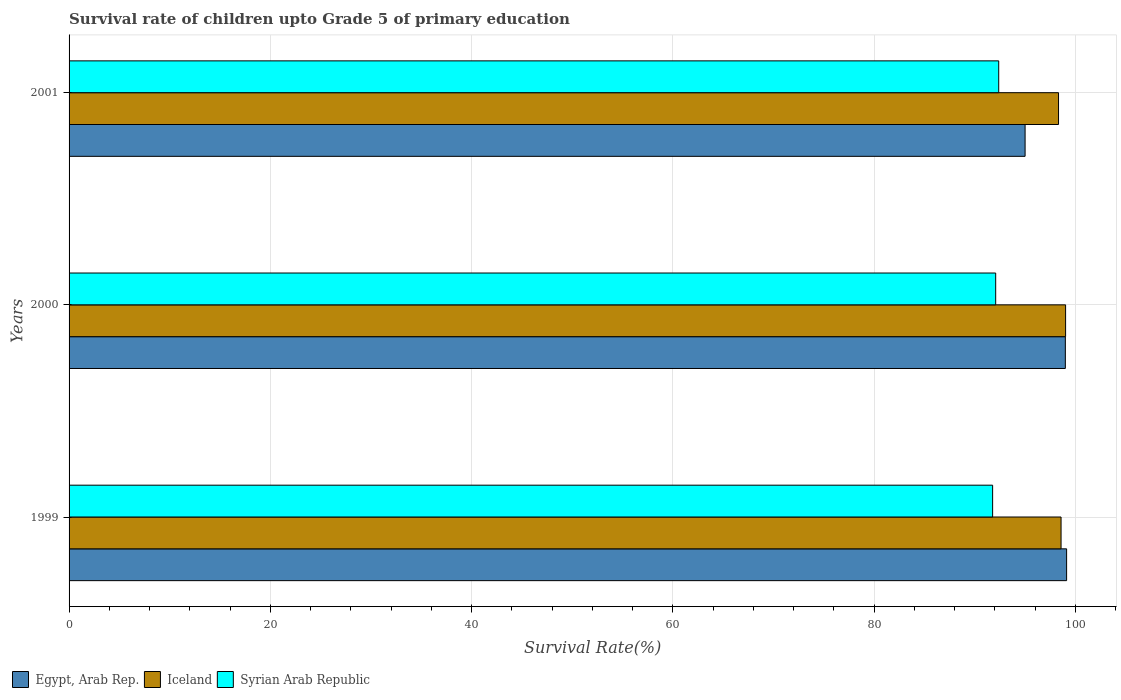Are the number of bars per tick equal to the number of legend labels?
Make the answer very short. Yes. Are the number of bars on each tick of the Y-axis equal?
Give a very brief answer. Yes. How many bars are there on the 3rd tick from the top?
Make the answer very short. 3. How many bars are there on the 2nd tick from the bottom?
Your answer should be very brief. 3. What is the label of the 2nd group of bars from the top?
Offer a terse response. 2000. What is the survival rate of children in Egypt, Arab Rep. in 1999?
Ensure brevity in your answer.  99.12. Across all years, what is the maximum survival rate of children in Egypt, Arab Rep.?
Provide a succinct answer. 99.12. Across all years, what is the minimum survival rate of children in Egypt, Arab Rep.?
Ensure brevity in your answer.  95. In which year was the survival rate of children in Iceland maximum?
Offer a very short reply. 2000. In which year was the survival rate of children in Egypt, Arab Rep. minimum?
Give a very brief answer. 2001. What is the total survival rate of children in Egypt, Arab Rep. in the graph?
Your answer should be very brief. 293.12. What is the difference between the survival rate of children in Iceland in 1999 and that in 2000?
Ensure brevity in your answer.  -0.45. What is the difference between the survival rate of children in Syrian Arab Republic in 2000 and the survival rate of children in Iceland in 2001?
Give a very brief answer. -6.24. What is the average survival rate of children in Egypt, Arab Rep. per year?
Offer a very short reply. 97.71. In the year 2000, what is the difference between the survival rate of children in Egypt, Arab Rep. and survival rate of children in Iceland?
Your answer should be very brief. -0.02. In how many years, is the survival rate of children in Egypt, Arab Rep. greater than 36 %?
Keep it short and to the point. 3. What is the ratio of the survival rate of children in Iceland in 1999 to that in 2001?
Keep it short and to the point. 1. Is the survival rate of children in Iceland in 1999 less than that in 2000?
Provide a short and direct response. Yes. What is the difference between the highest and the second highest survival rate of children in Syrian Arab Republic?
Offer a terse response. 0.3. What is the difference between the highest and the lowest survival rate of children in Egypt, Arab Rep.?
Your response must be concise. 4.13. In how many years, is the survival rate of children in Syrian Arab Republic greater than the average survival rate of children in Syrian Arab Republic taken over all years?
Provide a succinct answer. 2. What does the 1st bar from the top in 2001 represents?
Your response must be concise. Syrian Arab Republic. What does the 1st bar from the bottom in 2001 represents?
Your response must be concise. Egypt, Arab Rep. How many bars are there?
Provide a succinct answer. 9. Are all the bars in the graph horizontal?
Provide a succinct answer. Yes. Does the graph contain any zero values?
Your response must be concise. No. How are the legend labels stacked?
Make the answer very short. Horizontal. What is the title of the graph?
Make the answer very short. Survival rate of children upto Grade 5 of primary education. What is the label or title of the X-axis?
Offer a terse response. Survival Rate(%). What is the Survival Rate(%) of Egypt, Arab Rep. in 1999?
Give a very brief answer. 99.12. What is the Survival Rate(%) in Iceland in 1999?
Your answer should be compact. 98.57. What is the Survival Rate(%) of Syrian Arab Republic in 1999?
Offer a terse response. 91.77. What is the Survival Rate(%) in Egypt, Arab Rep. in 2000?
Your response must be concise. 99. What is the Survival Rate(%) of Iceland in 2000?
Ensure brevity in your answer.  99.02. What is the Survival Rate(%) in Syrian Arab Republic in 2000?
Ensure brevity in your answer.  92.08. What is the Survival Rate(%) of Egypt, Arab Rep. in 2001?
Ensure brevity in your answer.  95. What is the Survival Rate(%) in Iceland in 2001?
Offer a terse response. 98.32. What is the Survival Rate(%) in Syrian Arab Republic in 2001?
Make the answer very short. 92.38. Across all years, what is the maximum Survival Rate(%) of Egypt, Arab Rep.?
Your answer should be very brief. 99.12. Across all years, what is the maximum Survival Rate(%) in Iceland?
Offer a very short reply. 99.02. Across all years, what is the maximum Survival Rate(%) in Syrian Arab Republic?
Provide a succinct answer. 92.38. Across all years, what is the minimum Survival Rate(%) in Egypt, Arab Rep.?
Make the answer very short. 95. Across all years, what is the minimum Survival Rate(%) in Iceland?
Offer a very short reply. 98.32. Across all years, what is the minimum Survival Rate(%) in Syrian Arab Republic?
Provide a short and direct response. 91.77. What is the total Survival Rate(%) of Egypt, Arab Rep. in the graph?
Give a very brief answer. 293.12. What is the total Survival Rate(%) in Iceland in the graph?
Provide a succinct answer. 295.92. What is the total Survival Rate(%) in Syrian Arab Republic in the graph?
Offer a terse response. 276.23. What is the difference between the Survival Rate(%) in Egypt, Arab Rep. in 1999 and that in 2000?
Your response must be concise. 0.13. What is the difference between the Survival Rate(%) of Iceland in 1999 and that in 2000?
Offer a terse response. -0.45. What is the difference between the Survival Rate(%) of Syrian Arab Republic in 1999 and that in 2000?
Give a very brief answer. -0.3. What is the difference between the Survival Rate(%) in Egypt, Arab Rep. in 1999 and that in 2001?
Keep it short and to the point. 4.13. What is the difference between the Survival Rate(%) of Iceland in 1999 and that in 2001?
Make the answer very short. 0.25. What is the difference between the Survival Rate(%) in Syrian Arab Republic in 1999 and that in 2001?
Provide a succinct answer. -0.61. What is the difference between the Survival Rate(%) of Egypt, Arab Rep. in 2000 and that in 2001?
Ensure brevity in your answer.  4. What is the difference between the Survival Rate(%) in Iceland in 2000 and that in 2001?
Ensure brevity in your answer.  0.7. What is the difference between the Survival Rate(%) of Syrian Arab Republic in 2000 and that in 2001?
Offer a terse response. -0.3. What is the difference between the Survival Rate(%) of Egypt, Arab Rep. in 1999 and the Survival Rate(%) of Iceland in 2000?
Provide a succinct answer. 0.1. What is the difference between the Survival Rate(%) in Egypt, Arab Rep. in 1999 and the Survival Rate(%) in Syrian Arab Republic in 2000?
Provide a succinct answer. 7.05. What is the difference between the Survival Rate(%) in Iceland in 1999 and the Survival Rate(%) in Syrian Arab Republic in 2000?
Provide a succinct answer. 6.5. What is the difference between the Survival Rate(%) in Egypt, Arab Rep. in 1999 and the Survival Rate(%) in Iceland in 2001?
Offer a very short reply. 0.8. What is the difference between the Survival Rate(%) in Egypt, Arab Rep. in 1999 and the Survival Rate(%) in Syrian Arab Republic in 2001?
Your answer should be compact. 6.75. What is the difference between the Survival Rate(%) of Iceland in 1999 and the Survival Rate(%) of Syrian Arab Republic in 2001?
Give a very brief answer. 6.19. What is the difference between the Survival Rate(%) of Egypt, Arab Rep. in 2000 and the Survival Rate(%) of Iceland in 2001?
Make the answer very short. 0.68. What is the difference between the Survival Rate(%) in Egypt, Arab Rep. in 2000 and the Survival Rate(%) in Syrian Arab Republic in 2001?
Give a very brief answer. 6.62. What is the difference between the Survival Rate(%) of Iceland in 2000 and the Survival Rate(%) of Syrian Arab Republic in 2001?
Ensure brevity in your answer.  6.64. What is the average Survival Rate(%) of Egypt, Arab Rep. per year?
Give a very brief answer. 97.71. What is the average Survival Rate(%) in Iceland per year?
Your answer should be very brief. 98.64. What is the average Survival Rate(%) of Syrian Arab Republic per year?
Offer a terse response. 92.08. In the year 1999, what is the difference between the Survival Rate(%) in Egypt, Arab Rep. and Survival Rate(%) in Iceland?
Your response must be concise. 0.55. In the year 1999, what is the difference between the Survival Rate(%) in Egypt, Arab Rep. and Survival Rate(%) in Syrian Arab Republic?
Your answer should be compact. 7.35. In the year 1999, what is the difference between the Survival Rate(%) of Iceland and Survival Rate(%) of Syrian Arab Republic?
Offer a terse response. 6.8. In the year 2000, what is the difference between the Survival Rate(%) in Egypt, Arab Rep. and Survival Rate(%) in Iceland?
Give a very brief answer. -0.02. In the year 2000, what is the difference between the Survival Rate(%) of Egypt, Arab Rep. and Survival Rate(%) of Syrian Arab Republic?
Keep it short and to the point. 6.92. In the year 2000, what is the difference between the Survival Rate(%) of Iceland and Survival Rate(%) of Syrian Arab Republic?
Ensure brevity in your answer.  6.95. In the year 2001, what is the difference between the Survival Rate(%) of Egypt, Arab Rep. and Survival Rate(%) of Iceland?
Your answer should be very brief. -3.32. In the year 2001, what is the difference between the Survival Rate(%) of Egypt, Arab Rep. and Survival Rate(%) of Syrian Arab Republic?
Provide a short and direct response. 2.62. In the year 2001, what is the difference between the Survival Rate(%) of Iceland and Survival Rate(%) of Syrian Arab Republic?
Give a very brief answer. 5.94. What is the ratio of the Survival Rate(%) in Egypt, Arab Rep. in 1999 to that in 2000?
Your response must be concise. 1. What is the ratio of the Survival Rate(%) in Iceland in 1999 to that in 2000?
Your answer should be compact. 1. What is the ratio of the Survival Rate(%) of Syrian Arab Republic in 1999 to that in 2000?
Offer a very short reply. 1. What is the ratio of the Survival Rate(%) in Egypt, Arab Rep. in 1999 to that in 2001?
Offer a very short reply. 1.04. What is the ratio of the Survival Rate(%) of Syrian Arab Republic in 1999 to that in 2001?
Make the answer very short. 0.99. What is the ratio of the Survival Rate(%) of Egypt, Arab Rep. in 2000 to that in 2001?
Your answer should be very brief. 1.04. What is the ratio of the Survival Rate(%) of Iceland in 2000 to that in 2001?
Give a very brief answer. 1.01. What is the difference between the highest and the second highest Survival Rate(%) in Egypt, Arab Rep.?
Make the answer very short. 0.13. What is the difference between the highest and the second highest Survival Rate(%) of Iceland?
Ensure brevity in your answer.  0.45. What is the difference between the highest and the second highest Survival Rate(%) of Syrian Arab Republic?
Offer a terse response. 0.3. What is the difference between the highest and the lowest Survival Rate(%) in Egypt, Arab Rep.?
Ensure brevity in your answer.  4.13. What is the difference between the highest and the lowest Survival Rate(%) of Iceland?
Your response must be concise. 0.7. What is the difference between the highest and the lowest Survival Rate(%) in Syrian Arab Republic?
Give a very brief answer. 0.61. 